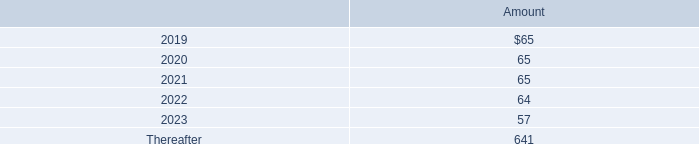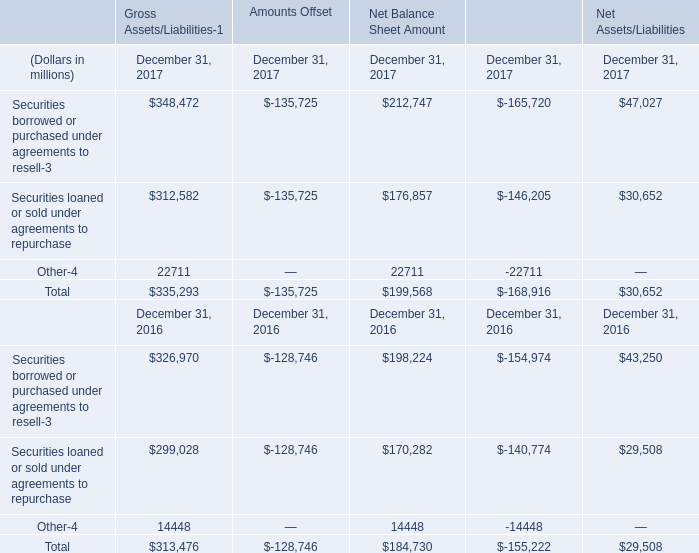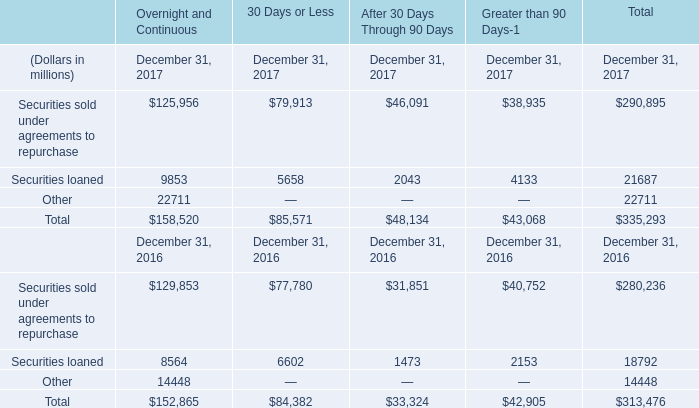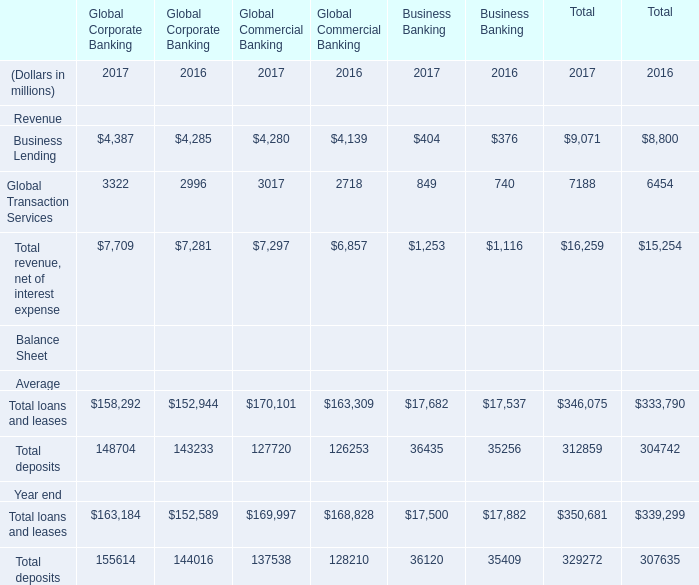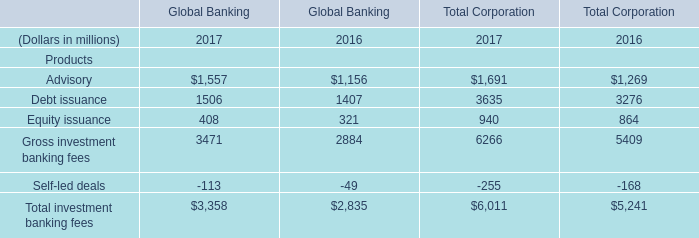What's the average of Gross investment banking fees of Global Banking 2017, and Other of Gross Assets/Liabilities December 31, 2017 ? 
Computations: ((3471.0 + 22711.0) / 2)
Answer: 13091.0. 